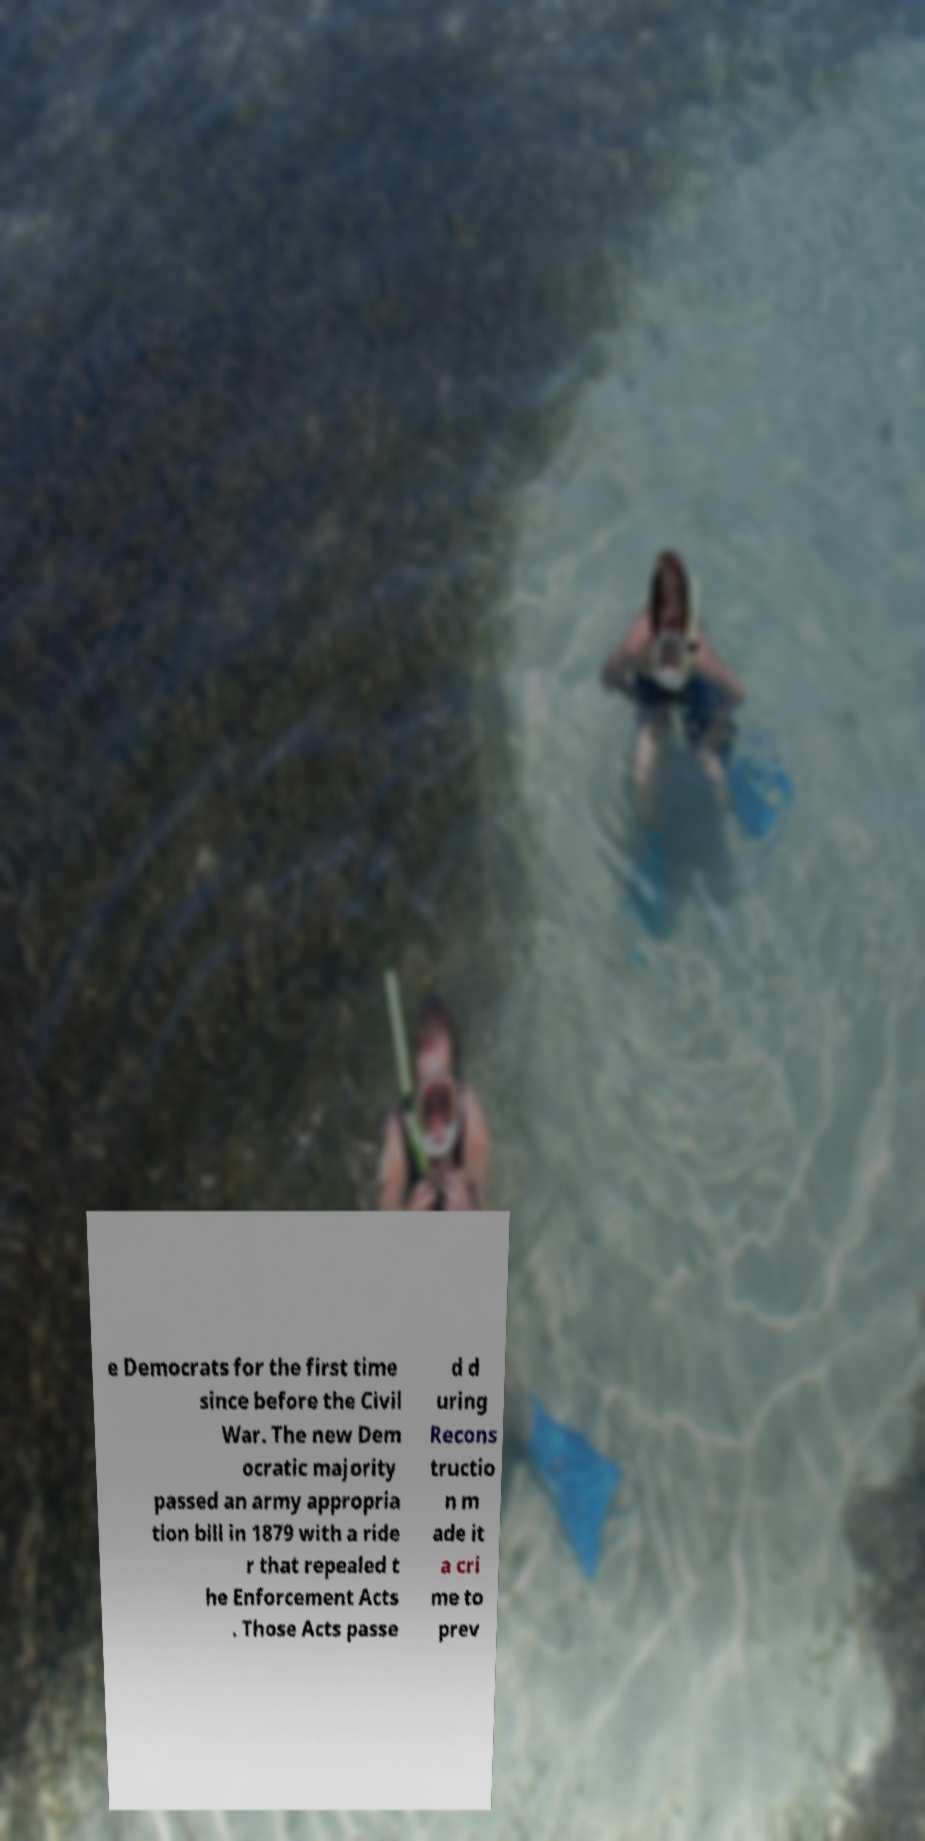Please read and relay the text visible in this image. What does it say? e Democrats for the first time since before the Civil War. The new Dem ocratic majority passed an army appropria tion bill in 1879 with a ride r that repealed t he Enforcement Acts . Those Acts passe d d uring Recons tructio n m ade it a cri me to prev 